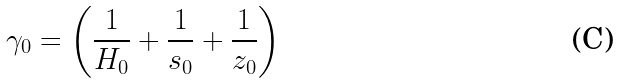Convert formula to latex. <formula><loc_0><loc_0><loc_500><loc_500>\gamma _ { 0 } = \left ( \frac { 1 } { H _ { 0 } } + \frac { 1 } { s _ { 0 } } + \frac { 1 } { z _ { 0 } } \right )</formula> 